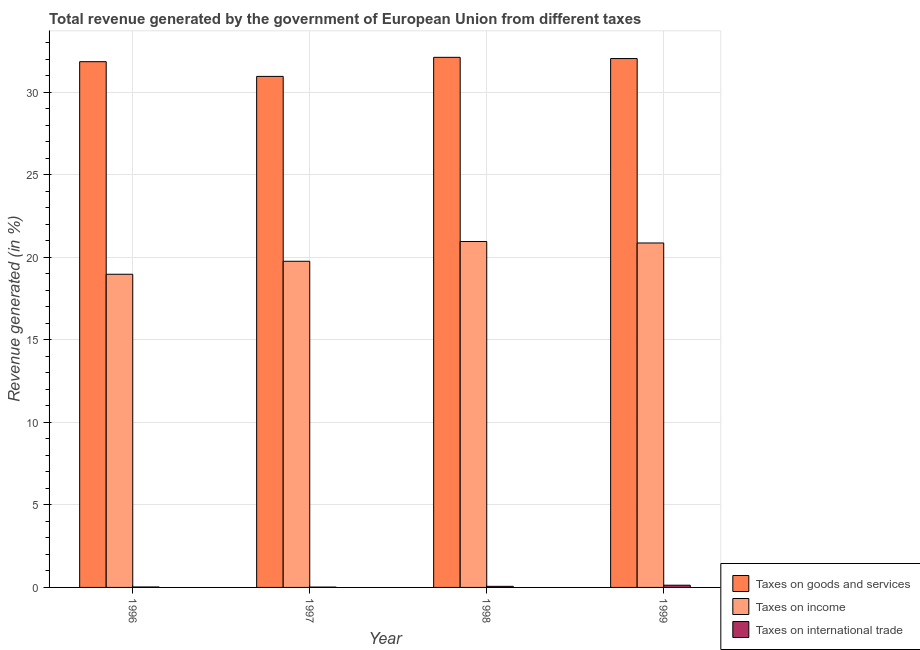Are the number of bars per tick equal to the number of legend labels?
Ensure brevity in your answer.  Yes. Are the number of bars on each tick of the X-axis equal?
Make the answer very short. Yes. How many bars are there on the 1st tick from the left?
Your response must be concise. 3. What is the percentage of revenue generated by taxes on income in 1998?
Your response must be concise. 20.96. Across all years, what is the maximum percentage of revenue generated by taxes on goods and services?
Offer a terse response. 32.12. Across all years, what is the minimum percentage of revenue generated by taxes on goods and services?
Your answer should be very brief. 30.97. In which year was the percentage of revenue generated by taxes on goods and services maximum?
Give a very brief answer. 1998. What is the total percentage of revenue generated by taxes on goods and services in the graph?
Keep it short and to the point. 127. What is the difference between the percentage of revenue generated by tax on international trade in 1998 and that in 1999?
Provide a short and direct response. -0.07. What is the difference between the percentage of revenue generated by tax on international trade in 1999 and the percentage of revenue generated by taxes on income in 1996?
Provide a short and direct response. 0.11. What is the average percentage of revenue generated by taxes on income per year?
Your answer should be very brief. 20.15. In the year 1996, what is the difference between the percentage of revenue generated by taxes on income and percentage of revenue generated by tax on international trade?
Your response must be concise. 0. In how many years, is the percentage of revenue generated by taxes on income greater than 19 %?
Make the answer very short. 3. What is the ratio of the percentage of revenue generated by taxes on income in 1997 to that in 1999?
Provide a succinct answer. 0.95. Is the percentage of revenue generated by tax on international trade in 1996 less than that in 1998?
Offer a terse response. Yes. Is the difference between the percentage of revenue generated by tax on international trade in 1996 and 1999 greater than the difference between the percentage of revenue generated by taxes on goods and services in 1996 and 1999?
Provide a succinct answer. No. What is the difference between the highest and the second highest percentage of revenue generated by taxes on goods and services?
Keep it short and to the point. 0.07. What is the difference between the highest and the lowest percentage of revenue generated by tax on international trade?
Make the answer very short. 0.11. Is the sum of the percentage of revenue generated by tax on international trade in 1996 and 1999 greater than the maximum percentage of revenue generated by taxes on income across all years?
Provide a short and direct response. Yes. What does the 3rd bar from the left in 1996 represents?
Your answer should be very brief. Taxes on international trade. What does the 3rd bar from the right in 1996 represents?
Offer a terse response. Taxes on goods and services. How many bars are there?
Your response must be concise. 12. What is the difference between two consecutive major ticks on the Y-axis?
Ensure brevity in your answer.  5. Are the values on the major ticks of Y-axis written in scientific E-notation?
Your answer should be very brief. No. Does the graph contain any zero values?
Ensure brevity in your answer.  No. Does the graph contain grids?
Make the answer very short. Yes. What is the title of the graph?
Make the answer very short. Total revenue generated by the government of European Union from different taxes. What is the label or title of the Y-axis?
Give a very brief answer. Revenue generated (in %). What is the Revenue generated (in %) in Taxes on goods and services in 1996?
Provide a succinct answer. 31.86. What is the Revenue generated (in %) of Taxes on income in 1996?
Provide a short and direct response. 18.98. What is the Revenue generated (in %) of Taxes on international trade in 1996?
Your answer should be very brief. 0.03. What is the Revenue generated (in %) of Taxes on goods and services in 1997?
Offer a terse response. 30.97. What is the Revenue generated (in %) in Taxes on income in 1997?
Offer a terse response. 19.77. What is the Revenue generated (in %) in Taxes on international trade in 1997?
Your response must be concise. 0.02. What is the Revenue generated (in %) in Taxes on goods and services in 1998?
Offer a very short reply. 32.12. What is the Revenue generated (in %) of Taxes on income in 1998?
Ensure brevity in your answer.  20.96. What is the Revenue generated (in %) of Taxes on international trade in 1998?
Your answer should be very brief. 0.07. What is the Revenue generated (in %) of Taxes on goods and services in 1999?
Your answer should be compact. 32.05. What is the Revenue generated (in %) of Taxes on income in 1999?
Your answer should be compact. 20.87. What is the Revenue generated (in %) in Taxes on international trade in 1999?
Ensure brevity in your answer.  0.13. Across all years, what is the maximum Revenue generated (in %) of Taxes on goods and services?
Provide a succinct answer. 32.12. Across all years, what is the maximum Revenue generated (in %) of Taxes on income?
Offer a terse response. 20.96. Across all years, what is the maximum Revenue generated (in %) in Taxes on international trade?
Provide a succinct answer. 0.13. Across all years, what is the minimum Revenue generated (in %) in Taxes on goods and services?
Provide a succinct answer. 30.97. Across all years, what is the minimum Revenue generated (in %) in Taxes on income?
Keep it short and to the point. 18.98. Across all years, what is the minimum Revenue generated (in %) of Taxes on international trade?
Your response must be concise. 0.02. What is the total Revenue generated (in %) in Taxes on goods and services in the graph?
Provide a short and direct response. 127. What is the total Revenue generated (in %) of Taxes on income in the graph?
Keep it short and to the point. 80.58. What is the total Revenue generated (in %) in Taxes on international trade in the graph?
Your answer should be compact. 0.25. What is the difference between the Revenue generated (in %) in Taxes on goods and services in 1996 and that in 1997?
Your answer should be compact. 0.89. What is the difference between the Revenue generated (in %) of Taxes on income in 1996 and that in 1997?
Your answer should be very brief. -0.79. What is the difference between the Revenue generated (in %) of Taxes on international trade in 1996 and that in 1997?
Your answer should be very brief. 0.01. What is the difference between the Revenue generated (in %) in Taxes on goods and services in 1996 and that in 1998?
Provide a short and direct response. -0.26. What is the difference between the Revenue generated (in %) in Taxes on income in 1996 and that in 1998?
Offer a terse response. -1.99. What is the difference between the Revenue generated (in %) in Taxes on international trade in 1996 and that in 1998?
Offer a very short reply. -0.04. What is the difference between the Revenue generated (in %) of Taxes on goods and services in 1996 and that in 1999?
Ensure brevity in your answer.  -0.19. What is the difference between the Revenue generated (in %) of Taxes on income in 1996 and that in 1999?
Ensure brevity in your answer.  -1.9. What is the difference between the Revenue generated (in %) in Taxes on international trade in 1996 and that in 1999?
Keep it short and to the point. -0.11. What is the difference between the Revenue generated (in %) of Taxes on goods and services in 1997 and that in 1998?
Give a very brief answer. -1.16. What is the difference between the Revenue generated (in %) of Taxes on income in 1997 and that in 1998?
Keep it short and to the point. -1.2. What is the difference between the Revenue generated (in %) of Taxes on international trade in 1997 and that in 1998?
Offer a very short reply. -0.05. What is the difference between the Revenue generated (in %) of Taxes on goods and services in 1997 and that in 1999?
Your answer should be very brief. -1.08. What is the difference between the Revenue generated (in %) of Taxes on income in 1997 and that in 1999?
Make the answer very short. -1.11. What is the difference between the Revenue generated (in %) of Taxes on international trade in 1997 and that in 1999?
Keep it short and to the point. -0.11. What is the difference between the Revenue generated (in %) of Taxes on goods and services in 1998 and that in 1999?
Provide a short and direct response. 0.07. What is the difference between the Revenue generated (in %) in Taxes on income in 1998 and that in 1999?
Provide a short and direct response. 0.09. What is the difference between the Revenue generated (in %) in Taxes on international trade in 1998 and that in 1999?
Offer a terse response. -0.07. What is the difference between the Revenue generated (in %) of Taxes on goods and services in 1996 and the Revenue generated (in %) of Taxes on income in 1997?
Your answer should be compact. 12.1. What is the difference between the Revenue generated (in %) of Taxes on goods and services in 1996 and the Revenue generated (in %) of Taxes on international trade in 1997?
Ensure brevity in your answer.  31.84. What is the difference between the Revenue generated (in %) in Taxes on income in 1996 and the Revenue generated (in %) in Taxes on international trade in 1997?
Provide a succinct answer. 18.96. What is the difference between the Revenue generated (in %) in Taxes on goods and services in 1996 and the Revenue generated (in %) in Taxes on income in 1998?
Ensure brevity in your answer.  10.9. What is the difference between the Revenue generated (in %) of Taxes on goods and services in 1996 and the Revenue generated (in %) of Taxes on international trade in 1998?
Provide a short and direct response. 31.79. What is the difference between the Revenue generated (in %) in Taxes on income in 1996 and the Revenue generated (in %) in Taxes on international trade in 1998?
Offer a very short reply. 18.91. What is the difference between the Revenue generated (in %) in Taxes on goods and services in 1996 and the Revenue generated (in %) in Taxes on income in 1999?
Ensure brevity in your answer.  10.99. What is the difference between the Revenue generated (in %) of Taxes on goods and services in 1996 and the Revenue generated (in %) of Taxes on international trade in 1999?
Your response must be concise. 31.73. What is the difference between the Revenue generated (in %) of Taxes on income in 1996 and the Revenue generated (in %) of Taxes on international trade in 1999?
Provide a short and direct response. 18.84. What is the difference between the Revenue generated (in %) of Taxes on goods and services in 1997 and the Revenue generated (in %) of Taxes on income in 1998?
Keep it short and to the point. 10. What is the difference between the Revenue generated (in %) of Taxes on goods and services in 1997 and the Revenue generated (in %) of Taxes on international trade in 1998?
Offer a very short reply. 30.9. What is the difference between the Revenue generated (in %) in Taxes on income in 1997 and the Revenue generated (in %) in Taxes on international trade in 1998?
Provide a short and direct response. 19.7. What is the difference between the Revenue generated (in %) in Taxes on goods and services in 1997 and the Revenue generated (in %) in Taxes on income in 1999?
Offer a terse response. 10.09. What is the difference between the Revenue generated (in %) in Taxes on goods and services in 1997 and the Revenue generated (in %) in Taxes on international trade in 1999?
Ensure brevity in your answer.  30.83. What is the difference between the Revenue generated (in %) in Taxes on income in 1997 and the Revenue generated (in %) in Taxes on international trade in 1999?
Provide a short and direct response. 19.63. What is the difference between the Revenue generated (in %) of Taxes on goods and services in 1998 and the Revenue generated (in %) of Taxes on income in 1999?
Your response must be concise. 11.25. What is the difference between the Revenue generated (in %) of Taxes on goods and services in 1998 and the Revenue generated (in %) of Taxes on international trade in 1999?
Ensure brevity in your answer.  31.99. What is the difference between the Revenue generated (in %) of Taxes on income in 1998 and the Revenue generated (in %) of Taxes on international trade in 1999?
Offer a terse response. 20.83. What is the average Revenue generated (in %) in Taxes on goods and services per year?
Make the answer very short. 31.75. What is the average Revenue generated (in %) in Taxes on income per year?
Offer a very short reply. 20.15. What is the average Revenue generated (in %) in Taxes on international trade per year?
Give a very brief answer. 0.06. In the year 1996, what is the difference between the Revenue generated (in %) in Taxes on goods and services and Revenue generated (in %) in Taxes on income?
Provide a succinct answer. 12.88. In the year 1996, what is the difference between the Revenue generated (in %) of Taxes on goods and services and Revenue generated (in %) of Taxes on international trade?
Offer a terse response. 31.83. In the year 1996, what is the difference between the Revenue generated (in %) in Taxes on income and Revenue generated (in %) in Taxes on international trade?
Ensure brevity in your answer.  18.95. In the year 1997, what is the difference between the Revenue generated (in %) of Taxes on goods and services and Revenue generated (in %) of Taxes on income?
Your answer should be very brief. 11.2. In the year 1997, what is the difference between the Revenue generated (in %) in Taxes on goods and services and Revenue generated (in %) in Taxes on international trade?
Offer a terse response. 30.95. In the year 1997, what is the difference between the Revenue generated (in %) of Taxes on income and Revenue generated (in %) of Taxes on international trade?
Make the answer very short. 19.75. In the year 1998, what is the difference between the Revenue generated (in %) in Taxes on goods and services and Revenue generated (in %) in Taxes on income?
Keep it short and to the point. 11.16. In the year 1998, what is the difference between the Revenue generated (in %) in Taxes on goods and services and Revenue generated (in %) in Taxes on international trade?
Your answer should be very brief. 32.06. In the year 1998, what is the difference between the Revenue generated (in %) of Taxes on income and Revenue generated (in %) of Taxes on international trade?
Offer a terse response. 20.9. In the year 1999, what is the difference between the Revenue generated (in %) of Taxes on goods and services and Revenue generated (in %) of Taxes on income?
Your response must be concise. 11.18. In the year 1999, what is the difference between the Revenue generated (in %) of Taxes on goods and services and Revenue generated (in %) of Taxes on international trade?
Offer a terse response. 31.92. In the year 1999, what is the difference between the Revenue generated (in %) of Taxes on income and Revenue generated (in %) of Taxes on international trade?
Offer a very short reply. 20.74. What is the ratio of the Revenue generated (in %) in Taxes on goods and services in 1996 to that in 1997?
Your response must be concise. 1.03. What is the ratio of the Revenue generated (in %) of Taxes on income in 1996 to that in 1997?
Offer a very short reply. 0.96. What is the ratio of the Revenue generated (in %) in Taxes on international trade in 1996 to that in 1997?
Ensure brevity in your answer.  1.32. What is the ratio of the Revenue generated (in %) of Taxes on goods and services in 1996 to that in 1998?
Your answer should be compact. 0.99. What is the ratio of the Revenue generated (in %) of Taxes on income in 1996 to that in 1998?
Make the answer very short. 0.91. What is the ratio of the Revenue generated (in %) of Taxes on international trade in 1996 to that in 1998?
Your answer should be compact. 0.41. What is the ratio of the Revenue generated (in %) in Taxes on goods and services in 1996 to that in 1999?
Offer a terse response. 0.99. What is the ratio of the Revenue generated (in %) in Taxes on income in 1996 to that in 1999?
Offer a terse response. 0.91. What is the ratio of the Revenue generated (in %) of Taxes on international trade in 1996 to that in 1999?
Keep it short and to the point. 0.2. What is the ratio of the Revenue generated (in %) of Taxes on income in 1997 to that in 1998?
Your answer should be compact. 0.94. What is the ratio of the Revenue generated (in %) in Taxes on international trade in 1997 to that in 1998?
Keep it short and to the point. 0.31. What is the ratio of the Revenue generated (in %) of Taxes on goods and services in 1997 to that in 1999?
Offer a terse response. 0.97. What is the ratio of the Revenue generated (in %) in Taxes on income in 1997 to that in 1999?
Provide a short and direct response. 0.95. What is the ratio of the Revenue generated (in %) of Taxes on international trade in 1997 to that in 1999?
Your response must be concise. 0.15. What is the ratio of the Revenue generated (in %) of Taxes on goods and services in 1998 to that in 1999?
Your response must be concise. 1. What is the ratio of the Revenue generated (in %) of Taxes on income in 1998 to that in 1999?
Provide a short and direct response. 1. What is the ratio of the Revenue generated (in %) in Taxes on international trade in 1998 to that in 1999?
Offer a very short reply. 0.49. What is the difference between the highest and the second highest Revenue generated (in %) in Taxes on goods and services?
Provide a short and direct response. 0.07. What is the difference between the highest and the second highest Revenue generated (in %) of Taxes on income?
Ensure brevity in your answer.  0.09. What is the difference between the highest and the second highest Revenue generated (in %) of Taxes on international trade?
Make the answer very short. 0.07. What is the difference between the highest and the lowest Revenue generated (in %) of Taxes on goods and services?
Your answer should be compact. 1.16. What is the difference between the highest and the lowest Revenue generated (in %) in Taxes on income?
Your response must be concise. 1.99. What is the difference between the highest and the lowest Revenue generated (in %) in Taxes on international trade?
Offer a terse response. 0.11. 